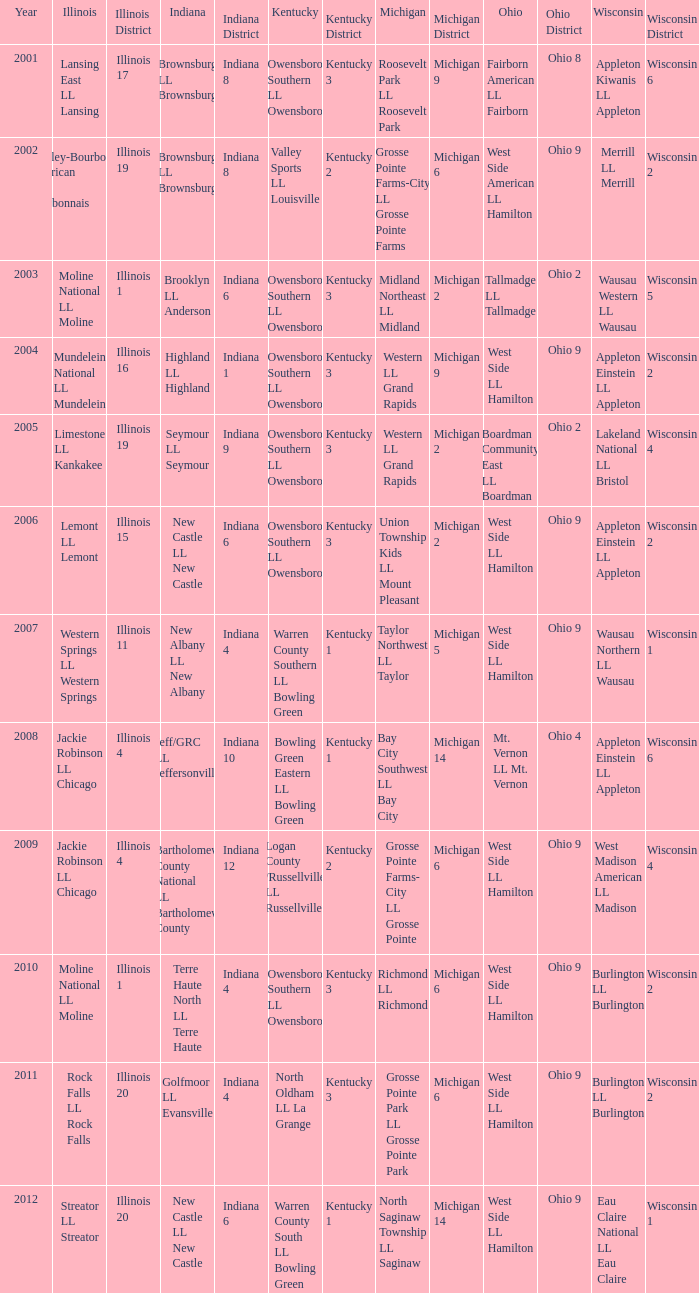What was the little league team from Michigan when the little league team from Indiana was Terre Haute North LL Terre Haute?  Richmond LL Richmond. 